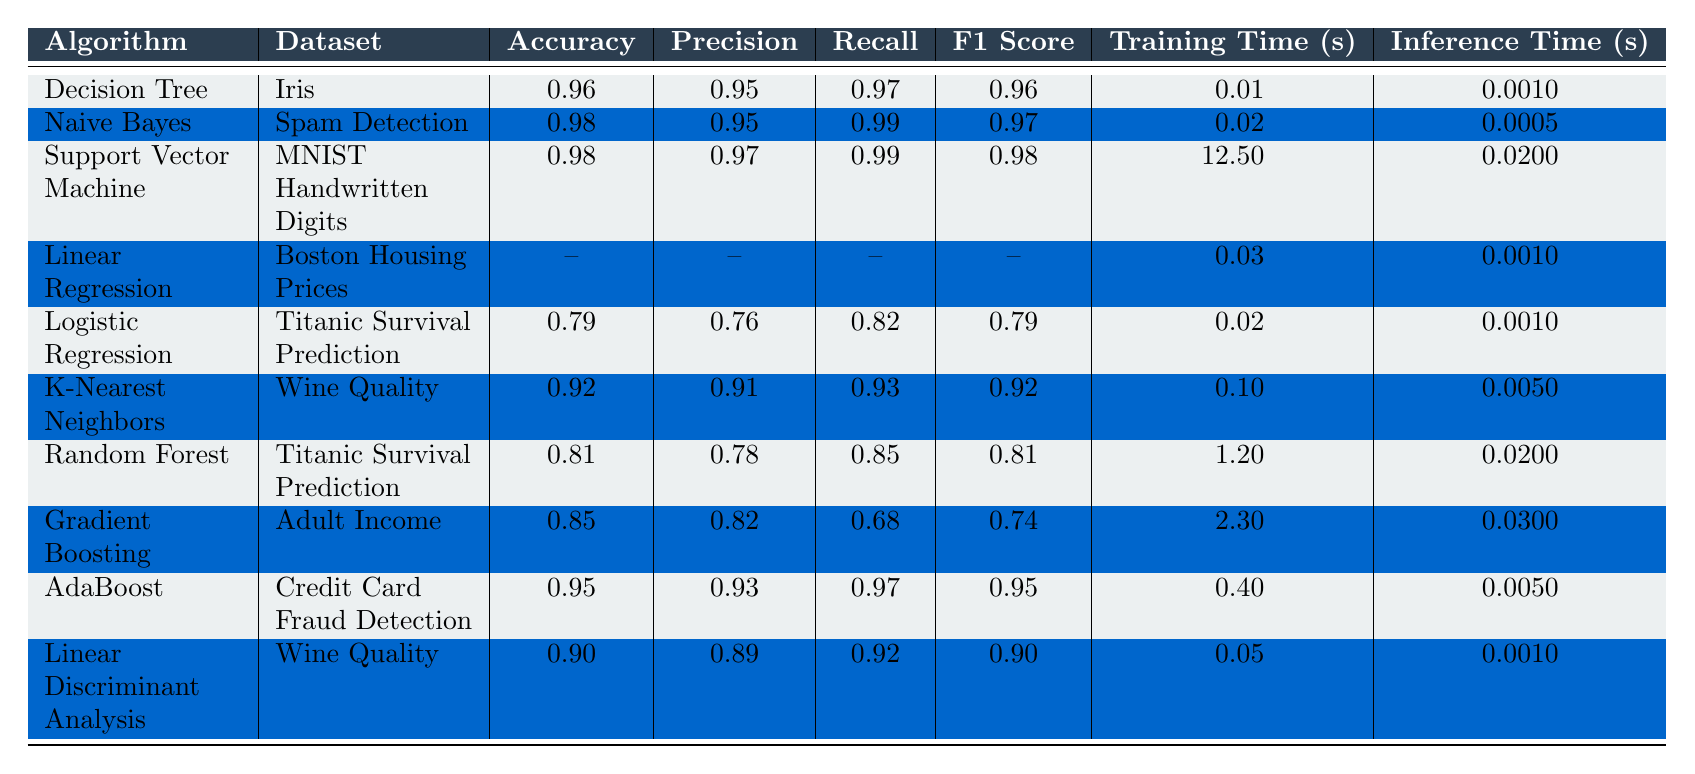What is the accuracy of the Naive Bayes algorithm on the Spam Detection dataset? The table shows that the accuracy for Naive Bayes on the Spam Detection dataset is listed specifically as 0.98.
Answer: 0.98 Which algorithm has the longest training time? By comparing the training times in the table, Support Vector Machine has the longest time at 12.5 seconds.
Answer: Support Vector Machine Does the Logistic Regression algorithm achieve an accuracy higher than 0.8? The table states that the accuracy of Logistic Regression on the Titanic Survival Prediction dataset is 0.79, which is less than 0.8.
Answer: No What is the average F1 Score of K-Nearest Neighbors and Random Forest algorithms? The F1 Score for K-Nearest Neighbors is 0.92 and for Random Forest is 0.81. Adding these gives a total of 1.73 and dividing by 2 gives an average F1 Score of 0.865.
Answer: 0.865 Which algorithm shows the highest recall and what is its value? From the table, both Naive Bayes and Support Vector Machine have the highest recall value of 0.99, making them tied for this metric.
Answer: 0.99 In terms of inference time, how much faster is Naive Bayes compared to Decision Tree? The inference time for Naive Bayes is 0.0005 seconds and for Decision Tree is 0.001 seconds. To find the difference, subtract 0.0005 from 0.001, which equals 0.0005 seconds.
Answer: 0.0005 seconds What are the precision values for both Linear Discriminant Analysis and Gradient Boosting algorithms? The table shows that Linear Discriminant Analysis has a precision of 0.89 and Gradient Boosting has a precision of 0.82, which can be directly retrieved from the table.
Answer: 0.89 and 0.82 Is the precision of the AdaBoost algorithm greater than that of the Random Forest algorithm? The precision of AdaBoost is 0.93 while that of Random Forest is 0.78, showing that AdaBoost indeed has a greater precision.
Answer: Yes What dataset was used for the Decision Tree algorithm? According to the table, the Decision Tree algorithm was applied to the Iris dataset.
Answer: Iris Which algorithm has better performance, in terms of accuracy, between Linear Regression and Random Forest? The accuracy for Linear Regression is not applicable in the table while Random Forest's accuracy is 0.81, indicating that we cannot compare the two based on accuracy.
Answer: Not applicable for comparison 